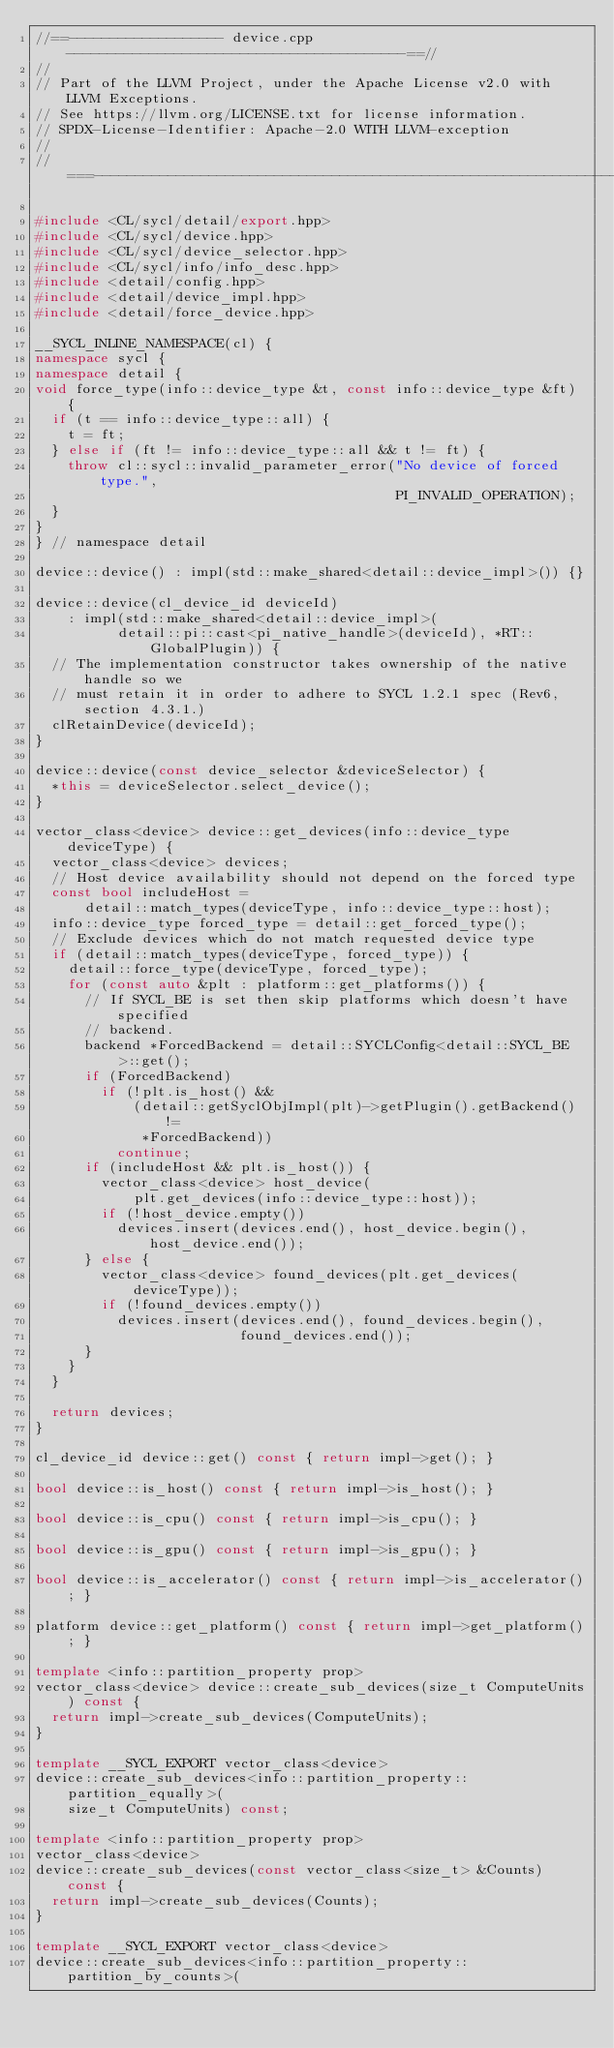<code> <loc_0><loc_0><loc_500><loc_500><_C++_>//==------------------- device.cpp -----------------------------------------==//
//
// Part of the LLVM Project, under the Apache License v2.0 with LLVM Exceptions.
// See https://llvm.org/LICENSE.txt for license information.
// SPDX-License-Identifier: Apache-2.0 WITH LLVM-exception
//
//===----------------------------------------------------------------------===//

#include <CL/sycl/detail/export.hpp>
#include <CL/sycl/device.hpp>
#include <CL/sycl/device_selector.hpp>
#include <CL/sycl/info/info_desc.hpp>
#include <detail/config.hpp>
#include <detail/device_impl.hpp>
#include <detail/force_device.hpp>

__SYCL_INLINE_NAMESPACE(cl) {
namespace sycl {
namespace detail {
void force_type(info::device_type &t, const info::device_type &ft) {
  if (t == info::device_type::all) {
    t = ft;
  } else if (ft != info::device_type::all && t != ft) {
    throw cl::sycl::invalid_parameter_error("No device of forced type.",
                                            PI_INVALID_OPERATION);
  }
}
} // namespace detail

device::device() : impl(std::make_shared<detail::device_impl>()) {}

device::device(cl_device_id deviceId)
    : impl(std::make_shared<detail::device_impl>(
          detail::pi::cast<pi_native_handle>(deviceId), *RT::GlobalPlugin)) {
  // The implementation constructor takes ownership of the native handle so we
  // must retain it in order to adhere to SYCL 1.2.1 spec (Rev6, section 4.3.1.)
  clRetainDevice(deviceId);
}

device::device(const device_selector &deviceSelector) {
  *this = deviceSelector.select_device();
}

vector_class<device> device::get_devices(info::device_type deviceType) {
  vector_class<device> devices;
  // Host device availability should not depend on the forced type
  const bool includeHost =
      detail::match_types(deviceType, info::device_type::host);
  info::device_type forced_type = detail::get_forced_type();
  // Exclude devices which do not match requested device type
  if (detail::match_types(deviceType, forced_type)) {
    detail::force_type(deviceType, forced_type);
    for (const auto &plt : platform::get_platforms()) {
      // If SYCL_BE is set then skip platforms which doesn't have specified
      // backend.
      backend *ForcedBackend = detail::SYCLConfig<detail::SYCL_BE>::get();
      if (ForcedBackend)
        if (!plt.is_host() &&
            (detail::getSyclObjImpl(plt)->getPlugin().getBackend() !=
             *ForcedBackend))
          continue;
      if (includeHost && plt.is_host()) {
        vector_class<device> host_device(
            plt.get_devices(info::device_type::host));
        if (!host_device.empty())
          devices.insert(devices.end(), host_device.begin(), host_device.end());
      } else {
        vector_class<device> found_devices(plt.get_devices(deviceType));
        if (!found_devices.empty())
          devices.insert(devices.end(), found_devices.begin(),
                         found_devices.end());
      }
    }
  }

  return devices;
}

cl_device_id device::get() const { return impl->get(); }

bool device::is_host() const { return impl->is_host(); }

bool device::is_cpu() const { return impl->is_cpu(); }

bool device::is_gpu() const { return impl->is_gpu(); }

bool device::is_accelerator() const { return impl->is_accelerator(); }

platform device::get_platform() const { return impl->get_platform(); }

template <info::partition_property prop>
vector_class<device> device::create_sub_devices(size_t ComputeUnits) const {
  return impl->create_sub_devices(ComputeUnits);
}

template __SYCL_EXPORT vector_class<device>
device::create_sub_devices<info::partition_property::partition_equally>(
    size_t ComputeUnits) const;

template <info::partition_property prop>
vector_class<device>
device::create_sub_devices(const vector_class<size_t> &Counts) const {
  return impl->create_sub_devices(Counts);
}

template __SYCL_EXPORT vector_class<device>
device::create_sub_devices<info::partition_property::partition_by_counts>(</code> 